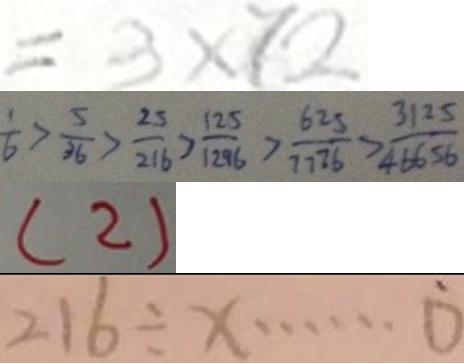Convert formula to latex. <formula><loc_0><loc_0><loc_500><loc_500>= 3 \times 7 2 
 \frac { 1 } { 6 } > \frac { 5 } { 3 6 } > \frac { 2 5 } { 2 1 6 } > \frac { 1 2 5 } { 1 2 9 6 } > \frac { 6 2 5 } { 7 7 7 6 } > \frac { 3 1 2 5 } { 4 6 6 5 6 } 
 ( 2 ) 
 2 1 6 \div x \cdots 0</formula> 